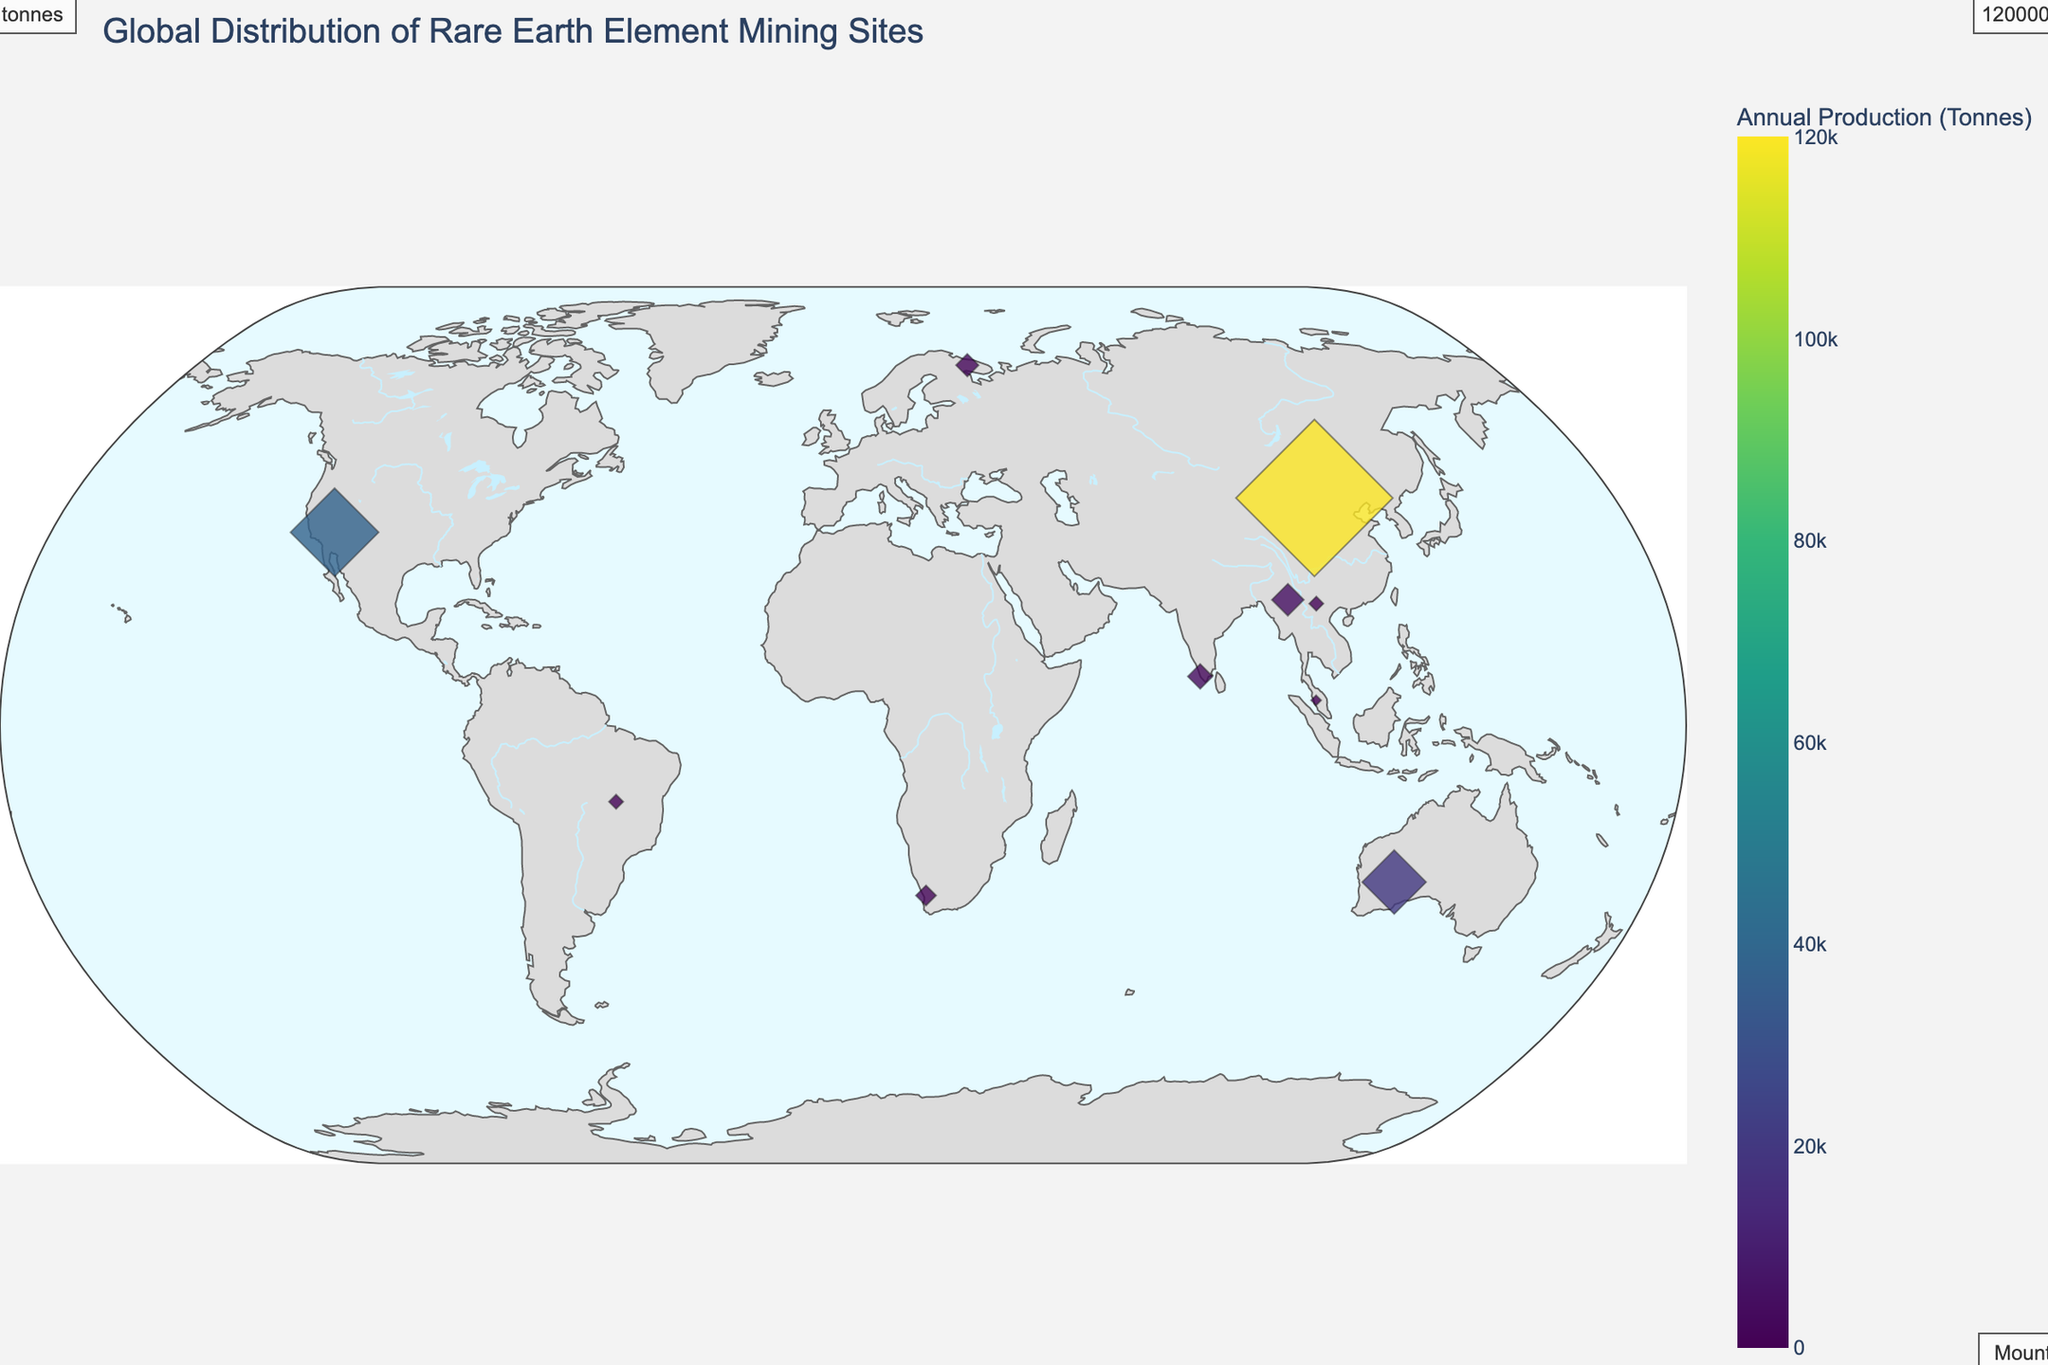What is the title of the plot? The title of the plot is displayed at the top and is "Global Distribution of Rare Earth Element Mining Sites".
Answer: Global Distribution of Rare Earth Element Mining Sites Which mine in the United States is shown on the map? By referring to the hover information for the United States, we see that the mine is labeled "Mountain Pass".
Answer: Mountain Pass How many mines are actively producing rare earth elements (non-zero production)? Count the number of mines with a non-zero production from the visual markers on the map. This includes China, Australia, United States, Russia, Brazil, India, Malaysia, South Africa, Myanmar, and Vietnam, making it a total of 10.
Answer: 10 What is the largest rare earth element mining site based on annual production? By looking at the size and color scale of the markers, the largest site based on production is in China, specifically the Bayan Obo mine.
Answer: Bayan Obo Estimate the total annual production of rare earth elements for the top 3 mining sites combined. From the annotations on the figure, the top 3 mines are Bayan Obo (120,000 tonnes), Mountain Pass (38,000 tonnes), and Mount Weld (20,000 tonnes). Summing these gives us 120,000 + 38,000 + 20,000 = 178,000 tonnes.
Answer: 178,000 tonnes Which mine is closest to the equator? Looking at the latitude values on the map's vertical axis, the mine with the latitude closest to zero is Chavara in India (8.9932).
Answer: Chavara What is the annual production of the mine located in Russia? Hover over Russia on the map and refer to the hover information for the Lovozero mine which shows an annual production of 2,500 tonnes.
Answer: 2,500 tonnes How does the production volume of Mount Weld in Australia compare to Steenkampskraal in South Africa? According to the annotations and hover information, Mount Weld produces 20,000 tonnes annually, while Steenkampskraal produces 2,000 tonnes. Therefore, Mount Weld produces significantly more.
Answer: Mount Weld produces more Which mines have a production volume of less than 1,000 tonnes annually? From the hover data and annotation information, the mines with less than 1,000 tonnes annual production are Perak in Malaysia (500 tonnes).
Answer: Perak Which countries have multiple sites listed, and what are their total production sums? Identify repeated countries and total the production. Vietnam is one such country with Lai Chau (1,000 tonnes). Another is India with Chavara (3,000 tonnes). The total for Vietnam is 1,000 tonnes, and for India, 3,000 tonnes.
Answer: Vietnam: 1,000 tonnes, India: 3,000 tonnes 